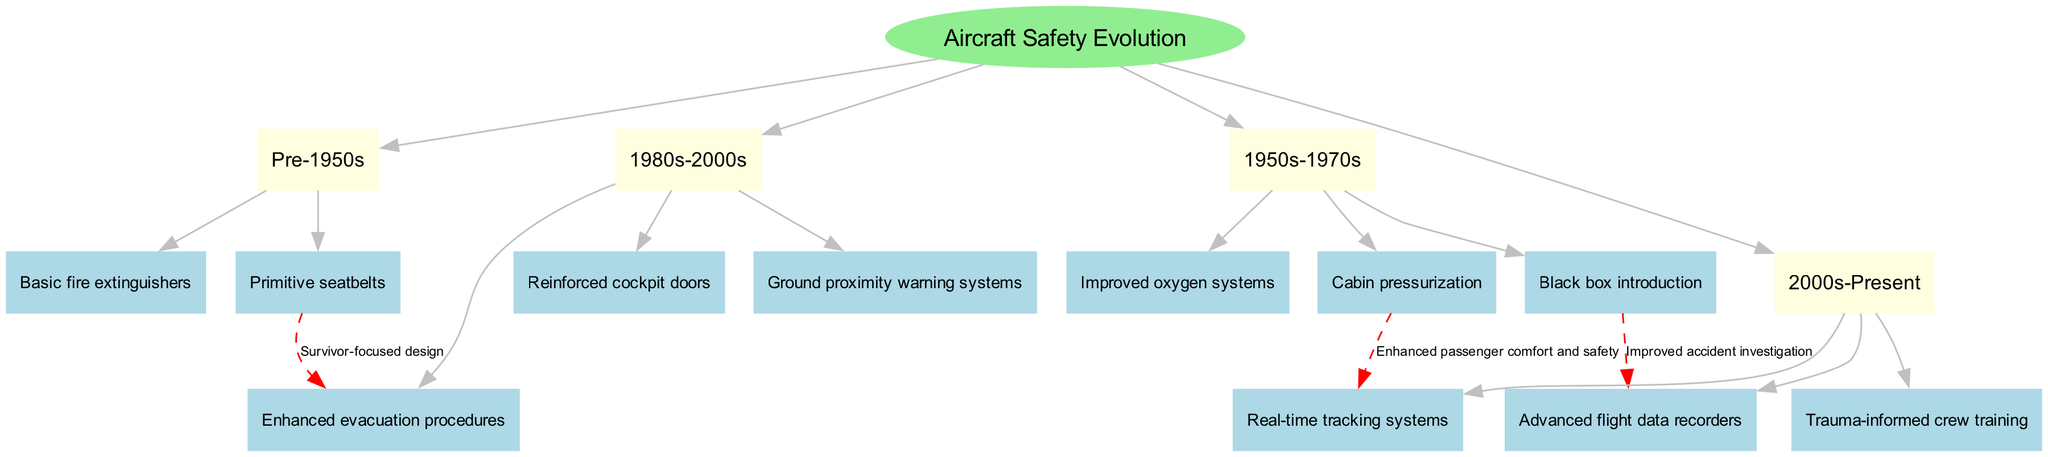What is the name of the root node? The root node is labeled "Aircraft Safety Evolution," which is the starting point of the family tree diagram.
Answer: Aircraft Safety Evolution How many branches are there in the diagram? The diagram contains four branches: "Pre-1950s," "1950s-1970s," "1980s-2000s," and "2000s-Present." Therefore, the total number of branches is four.
Answer: 4 What feature was introduced in the 1980s-2000s branch? The 1980s-2000s branch includes "Enhanced evacuation procedures," which is one of the safety features developed during this time period.
Answer: Enhanced evacuation procedures What connection is labeled as "Improved accident investigation"? The connection labeled "Improved accident investigation" links "Black box introduction" from the 1950s-1970s branch to "Advanced flight data recorders" in the 2000s-Present branch, indicating the evolution of safety features related to aircraft incident analysis.
Answer: Black box introduction to Advanced flight data recorders Which two features are connected by "Enhanced passenger comfort and safety"? The connection labeled "Enhanced passenger comfort and safety" exists between "Cabin pressurization" from the 1950s-1970s branch and "Real-time tracking systems" from the 2000s-Present branch.
Answer: Cabin pressurization and Real-time tracking systems Which feature from the Pre-1950s branch connects to procedures in the 1980s-2000s branch? The feature "Primitive seatbelts" from the Pre-1950s branch connects to "Enhanced evacuation procedures" in the 1980s-2000s branch, illustrating the progression of safety design focused on survivors.
Answer: Primitive seatbelts What safety feature was introduced alongside real-time tracking systems? "Advanced flight data recorders" is the safety feature that was introduced alongside "Real-time tracking systems" in the 2000s-Present branch, which emphasizes current advancements in tracking and data recording.
Answer: Advanced flight data recorders In which time period were improved oxygen systems introduced? Improved oxygen systems were introduced during the 1950s-1970s time period, as indicated within that branch of the family tree.
Answer: 1950s-1970s What is the total number of safety features listed in the 2000s-Present branch? The 2000s-Present branch lists three safety features: "Advanced flight data recorders," "Real-time tracking systems," and "Trauma-informed crew training," leading to a total of three features.
Answer: 3 